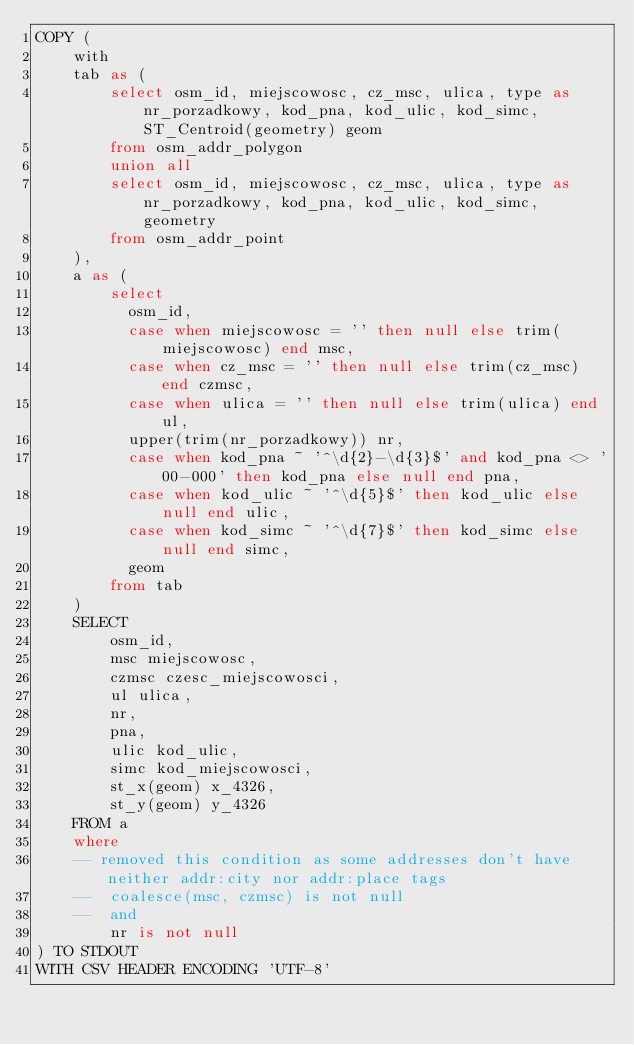<code> <loc_0><loc_0><loc_500><loc_500><_SQL_>COPY (
    with
    tab as (
        select osm_id, miejscowosc, cz_msc, ulica, type as nr_porzadkowy, kod_pna, kod_ulic, kod_simc, ST_Centroid(geometry) geom
        from osm_addr_polygon
        union all
        select osm_id, miejscowosc, cz_msc, ulica, type as nr_porzadkowy, kod_pna, kod_ulic, kod_simc, geometry
        from osm_addr_point
    ),
    a as (
        select
          osm_id,
          case when miejscowosc = '' then null else trim(miejscowosc) end msc,
          case when cz_msc = '' then null else trim(cz_msc) end czmsc,
          case when ulica = '' then null else trim(ulica) end ul,
          upper(trim(nr_porzadkowy)) nr,
          case when kod_pna ~ '^\d{2}-\d{3}$' and kod_pna <> '00-000' then kod_pna else null end pna,
          case when kod_ulic ~ '^\d{5}$' then kod_ulic else null end ulic,
          case when kod_simc ~ '^\d{7}$' then kod_simc else null end simc,
          geom
        from tab
    )
    SELECT
        osm_id,
        msc miejscowosc,
        czmsc czesc_miejscowosci,
        ul ulica,
        nr,
        pna,
        ulic kod_ulic,
        simc kod_miejscowosci,
        st_x(geom) x_4326,
        st_y(geom) y_4326
    FROM a
    where
    -- removed this condition as some addresses don't have neither addr:city nor addr:place tags
    --  coalesce(msc, czmsc) is not null
    --  and
        nr is not null
) TO STDOUT
WITH CSV HEADER ENCODING 'UTF-8'
</code> 